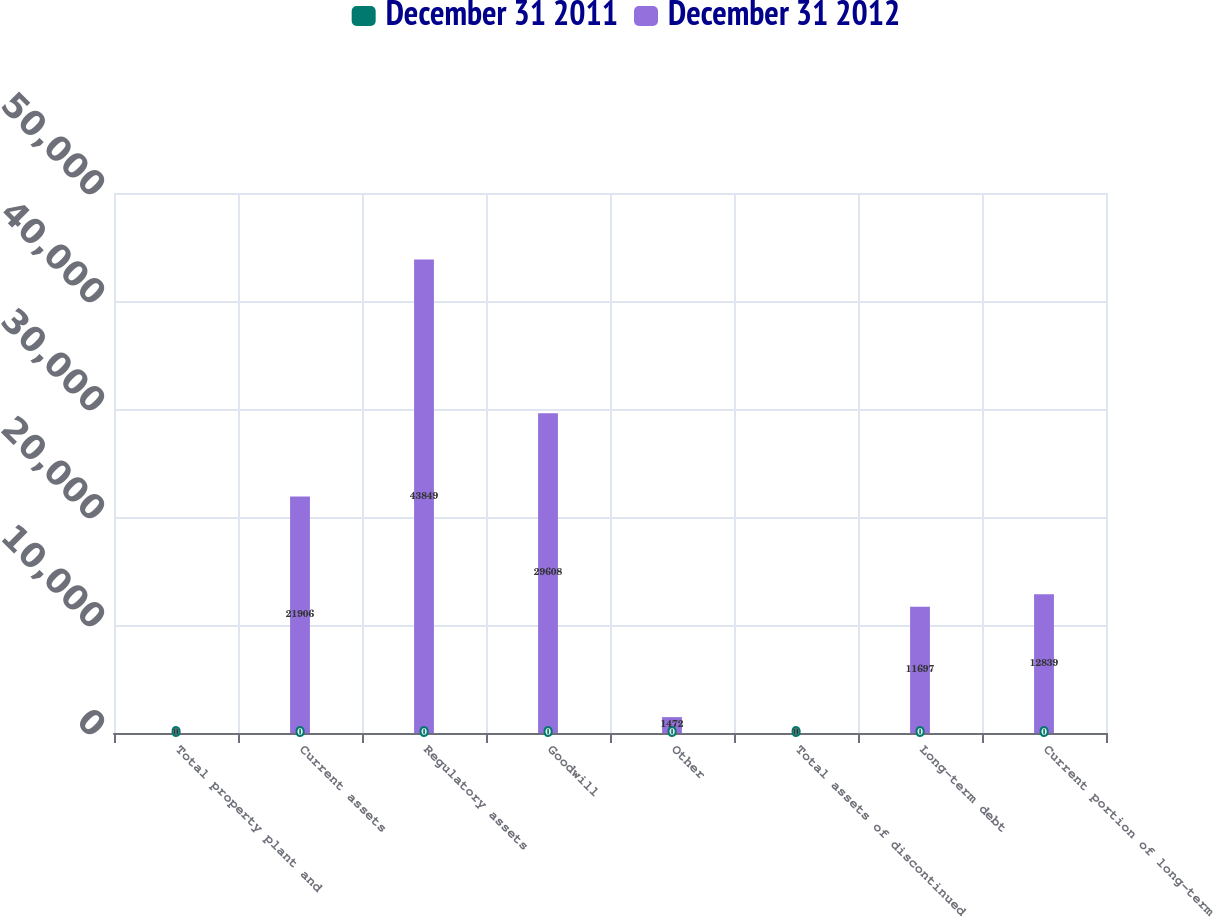<chart> <loc_0><loc_0><loc_500><loc_500><stacked_bar_chart><ecel><fcel>Total property plant and<fcel>Current assets<fcel>Regulatory assets<fcel>Goodwill<fcel>Other<fcel>Total assets of discontinued<fcel>Long-term debt<fcel>Current portion of long-term<nl><fcel>December 31 2011<fcel>0<fcel>0<fcel>0<fcel>0<fcel>0<fcel>0<fcel>0<fcel>0<nl><fcel>December 31 2012<fcel>0<fcel>21906<fcel>43849<fcel>29608<fcel>1472<fcel>0<fcel>11697<fcel>12839<nl></chart> 